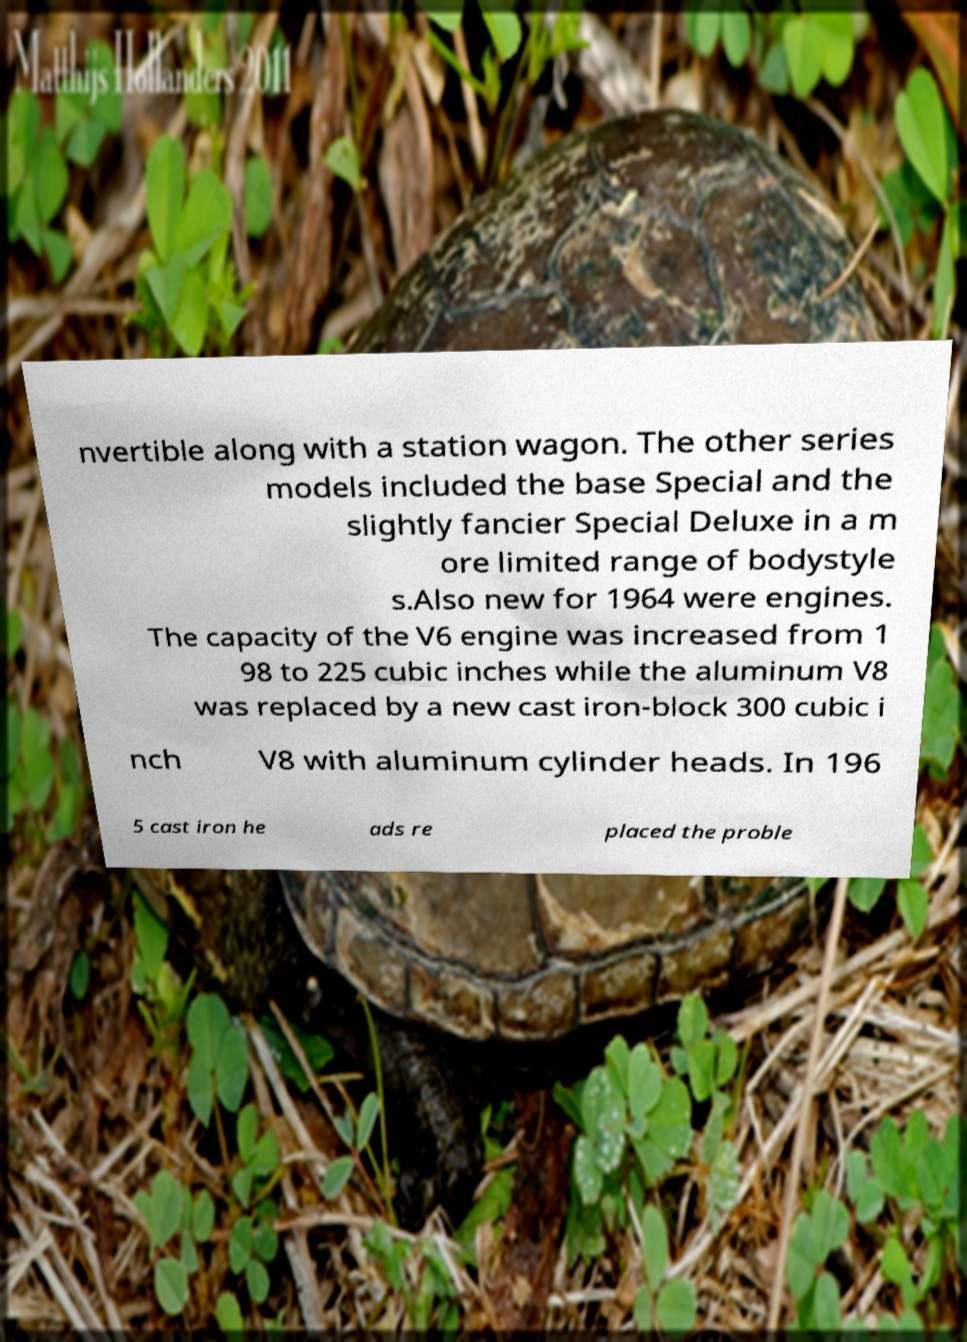Could you extract and type out the text from this image? nvertible along with a station wagon. The other series models included the base Special and the slightly fancier Special Deluxe in a m ore limited range of bodystyle s.Also new for 1964 were engines. The capacity of the V6 engine was increased from 1 98 to 225 cubic inches while the aluminum V8 was replaced by a new cast iron-block 300 cubic i nch V8 with aluminum cylinder heads. In 196 5 cast iron he ads re placed the proble 